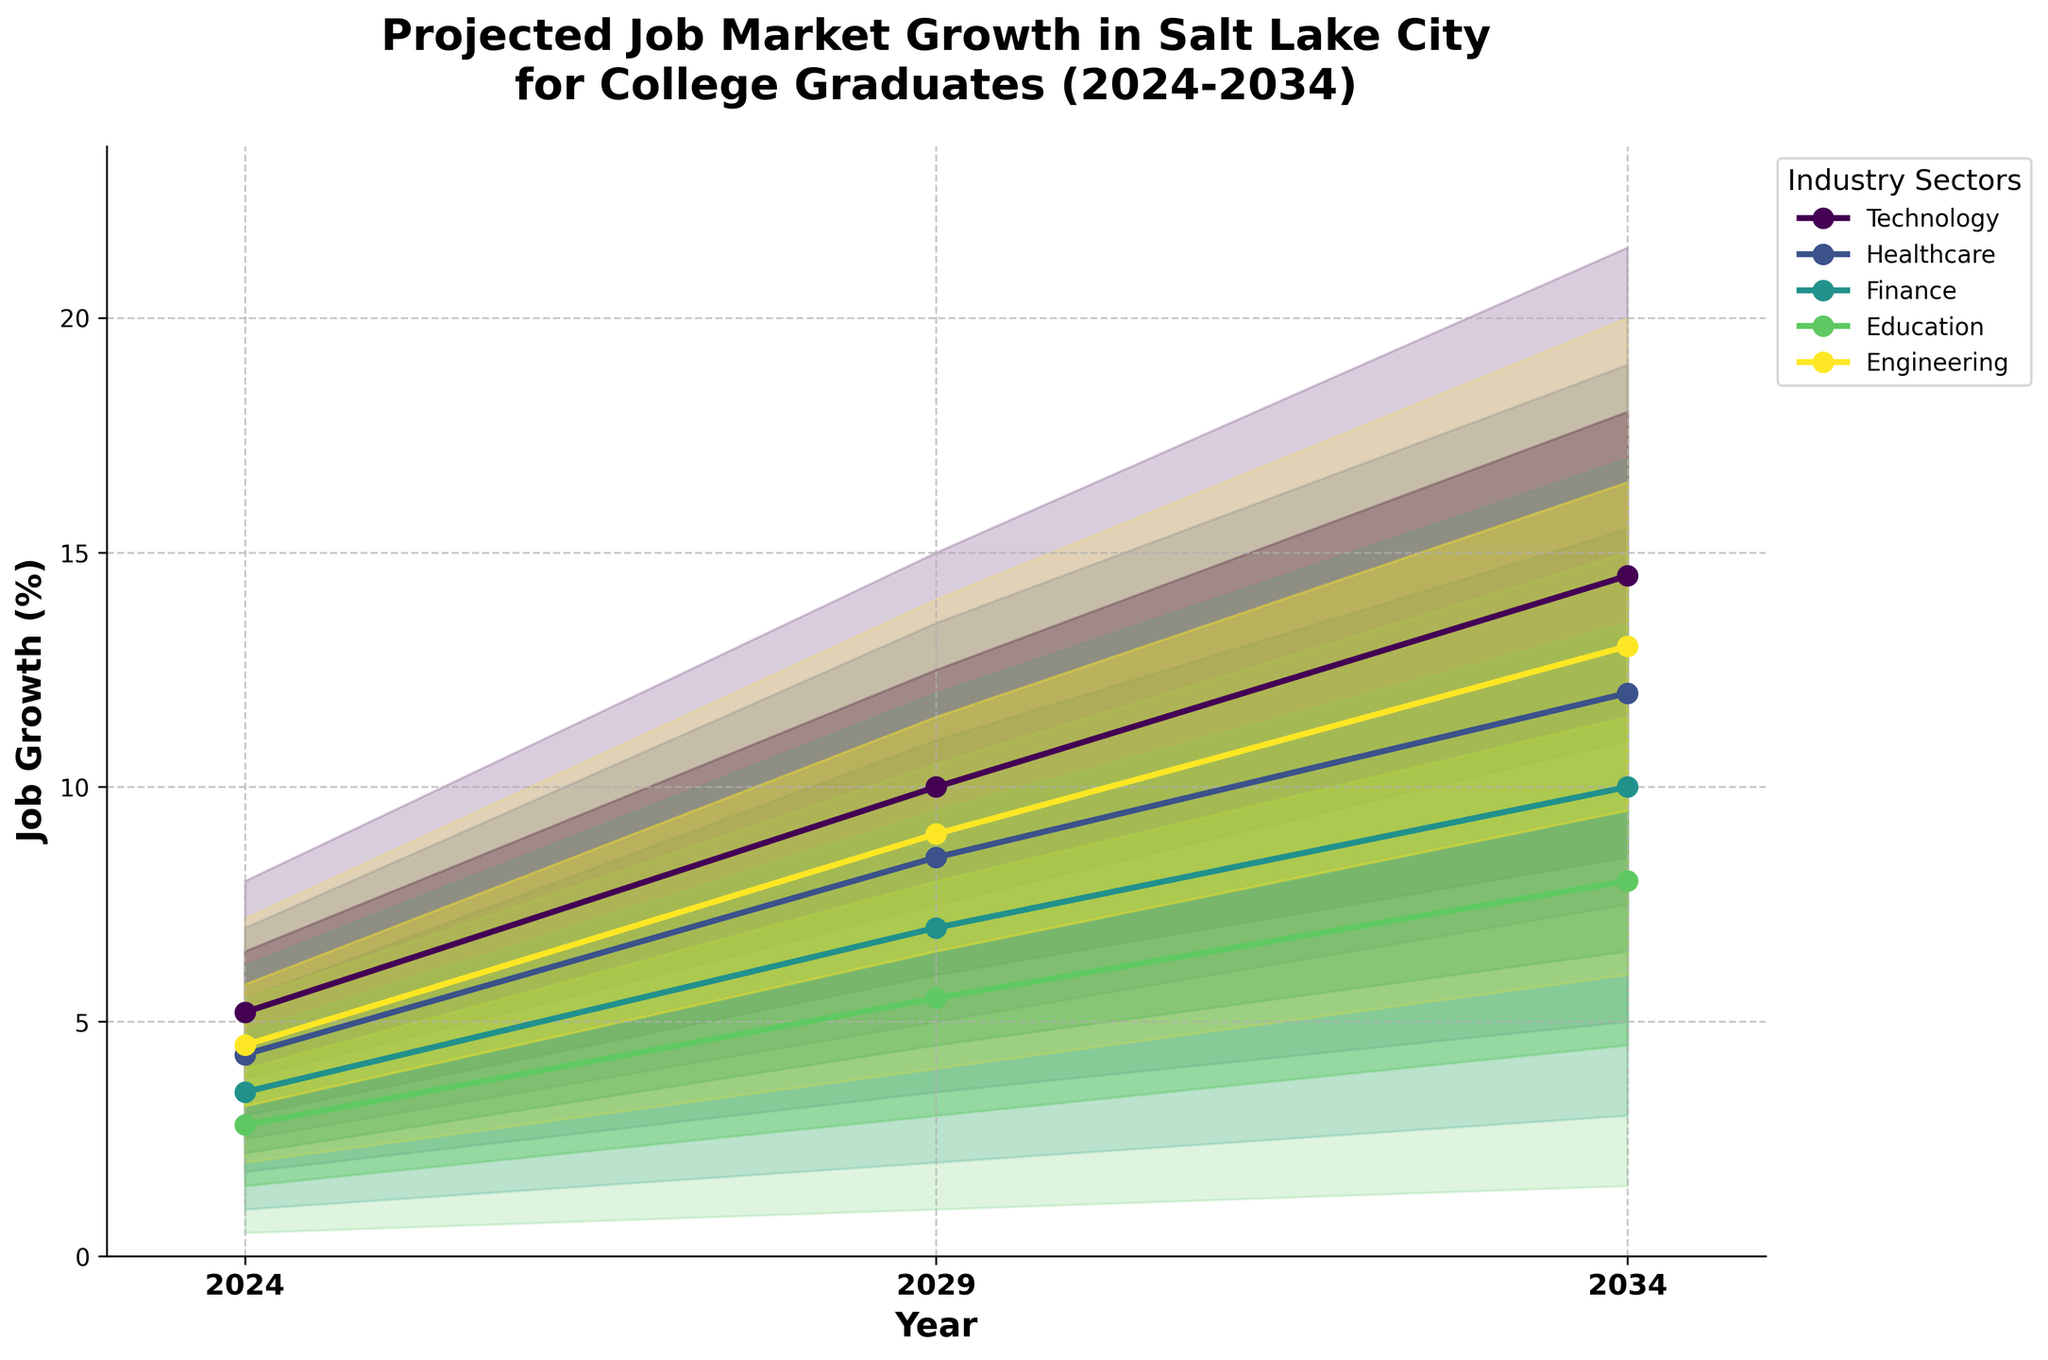How many different industry sectors are shown in the figure? The title indicates projections for multiple industries. By looking at the plot, we see different color-coded lines for each industry. The legend will list all these industries.
Answer: 5 What is the projected job growth percentage for the Technology sector in 2029 under the base scenario? Find the Technology sector in the legend, trace its line to the year 2029, and read the value on the y-axis associated with the base scenario (solid line).
Answer: 10.0% Which industry has the highest optimistic growth rate in 2034? Identify the growth rates under the optimistic scenario for each industry in 2034 by looking at the topmost boundaries of the shaded regions. Compare these values to find the highest one.
Answer: Technology Which sector has the smallest expected range of growth in 2029? Look at the shaded areas representing the range from pessimistic to optimistic scenarios for each sector in 2029. Identify the sector with the narrowest band (smallest distance between pessimistic and optimistic projections).
Answer: Education By how much does the base scenario job growth for Healthcare increase from 2024 to 2034? Find the base scenario growth percentages for Healthcare in 2024 and 2034. Subtract the 2024 value from the 2034 value to determine the increase.
Answer: 12.0 - 4.3 = 7.7% What is the difference between the optimistic and pessimistic growth projections for the Finance sector in 2034? Identify the optimistic and pessimistic projections for Finance in 2034. Subtract the pessimistic value from the optimistic value.
Answer: 17.0 - 3.0 = 14.0% Which sector shows the greatest increase in base scenario job growth from 2029 to 2034? Determine the base scenario job growth percentages for 2029 and 2034 for each sector. Find the difference for each sector and identify the one with the largest increase.
Answer: Technology Comparing the Technology and Healthcare sectors, which one shows a higher high-scenario job growth in 2029? Find the job growth values in the high scenario for both Technology and Healthcare in 2029. Compare these values to determine which is higher.
Answer: Technology Which sector has the lowest low-scenario job growth in 2024? Look for the "Low" scenario values for each sector in 2024. Identify the smallest value among them.
Answer: Education Is the job growth in the Engineering sector consistently increasing in the base scenario from 2024 to 2034? Examine the base scenario growth percentages for the Engineering sector in 2024, 2029, and 2034. Ensure each subsequent value is higher than the previous one.
Answer: Yes 